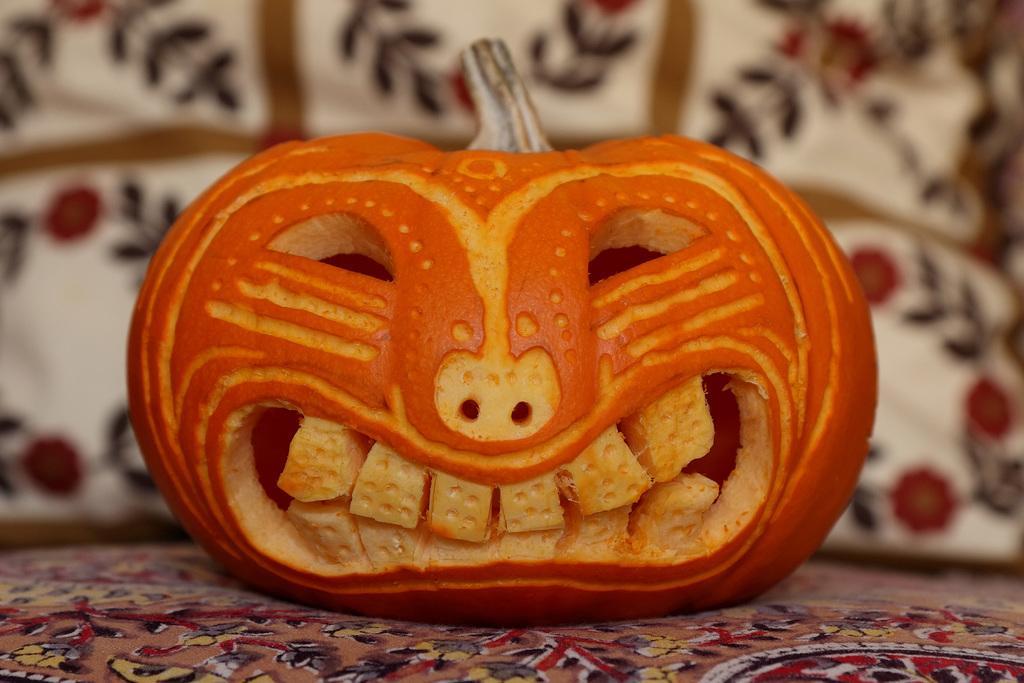Describe this image in one or two sentences. In this image I can see there is a pumpkin which is in orange color and it is shaped in the face of a human. Behind this it looks like a pillow, at the bottom there is the cloth. 